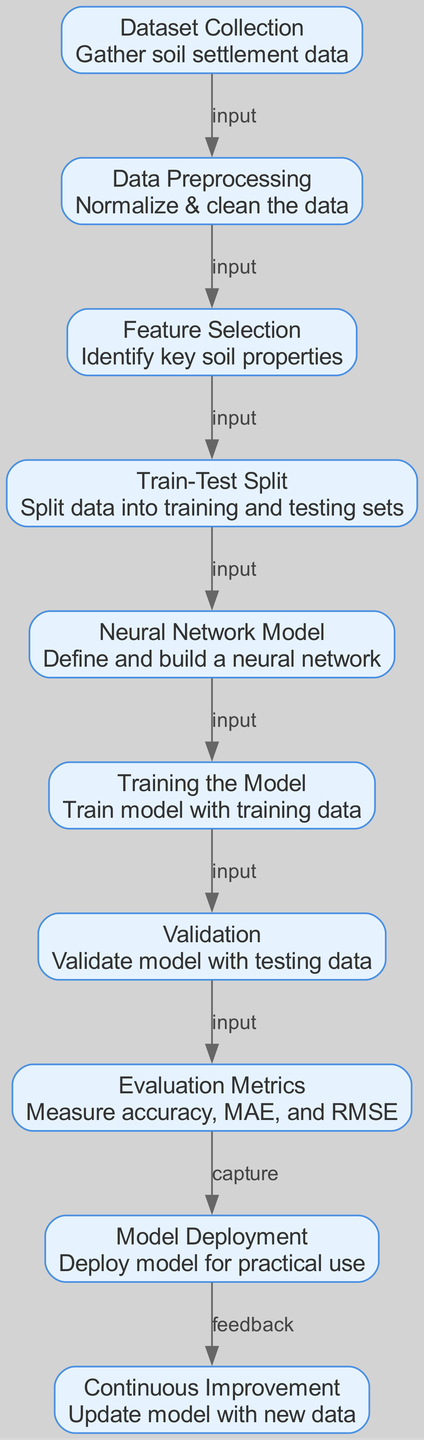What is the first step in the diagram? The first node is "Dataset Collection," which is identified as the starting point for gathering soil settlement data.
Answer: Dataset Collection How many nodes are in the diagram? By counting the individual nodes represented in the diagram, we find there are a total of ten nodes.
Answer: Ten What does the edge from "Neural Network Model" to "Training the Model" indicate? The edge labeled "input" from "Neural Network Model" to "Training the Model" implies that the neural network model is used as input for training the model with data.
Answer: Input Which node captures evaluation metrics? The node "Evaluation Metrics" is where the accuracy, mean absolute error, and root mean square error will be measured, making it the capturing point for such metrics.
Answer: Evaluation Metrics What is the relationship between "Validation" and "Evaluation Metrics"? The relationship is indicated by an edge labeled "input," meaning that the validation step uses the results from the training process to measure the evaluation metrics.
Answer: Input Which node follows after the "Model Deployment"? The "Continuous Improvement" node comes after "Model Deployment," indicating a feedback loop for updating the model with new data.
Answer: Continuous Improvement What happens after "Training the Model"? Following "Training the Model," there is a "Validation" phase, where the model is validated with testing data to check its performance.
Answer: Validation How many edges are there in the diagram? When counting all connections (edges) between nodes in the diagram, it results in a total of nine edges.
Answer: Nine What does the arrow from "Dataset Collection" to "Data Preprocessing" signify? This arrow labeled "input" illustrates that the data collected will be subjected to preprocessing in the next step for normalization and cleaning.
Answer: Input 